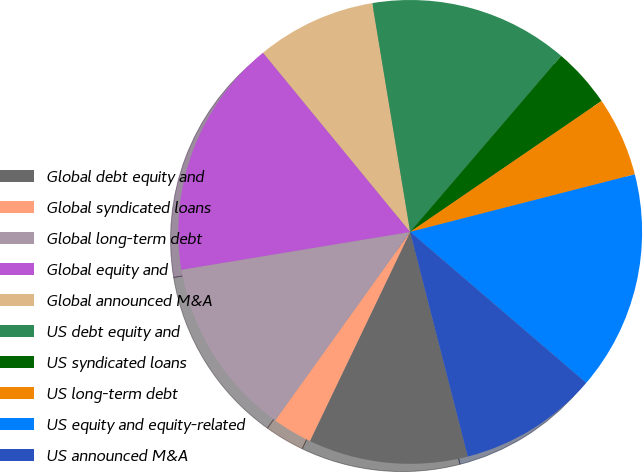Convert chart. <chart><loc_0><loc_0><loc_500><loc_500><pie_chart><fcel>Global debt equity and<fcel>Global syndicated loans<fcel>Global long-term debt<fcel>Global equity and<fcel>Global announced M&A<fcel>US debt equity and<fcel>US syndicated loans<fcel>US long-term debt<fcel>US equity and equity-related<fcel>US announced M&A<nl><fcel>11.11%<fcel>2.78%<fcel>12.5%<fcel>16.67%<fcel>8.33%<fcel>13.89%<fcel>4.17%<fcel>5.56%<fcel>15.28%<fcel>9.72%<nl></chart> 